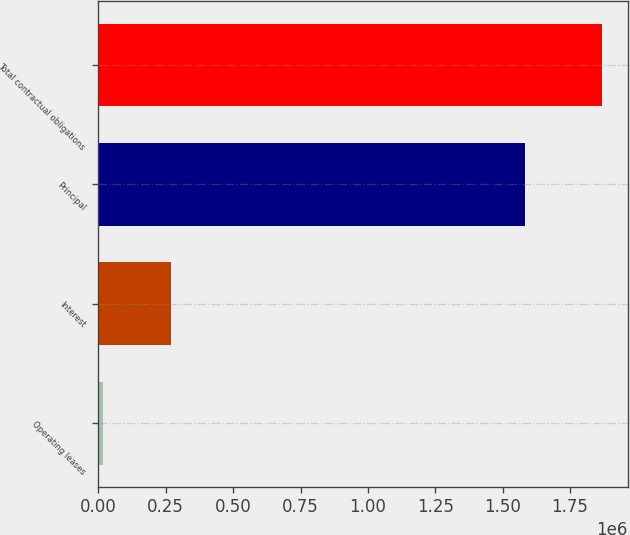<chart> <loc_0><loc_0><loc_500><loc_500><bar_chart><fcel>Operating leases<fcel>Interest<fcel>Principal<fcel>Total contractual obligations<nl><fcel>16444<fcel>269795<fcel>1.58354e+06<fcel>1.86978e+06<nl></chart> 